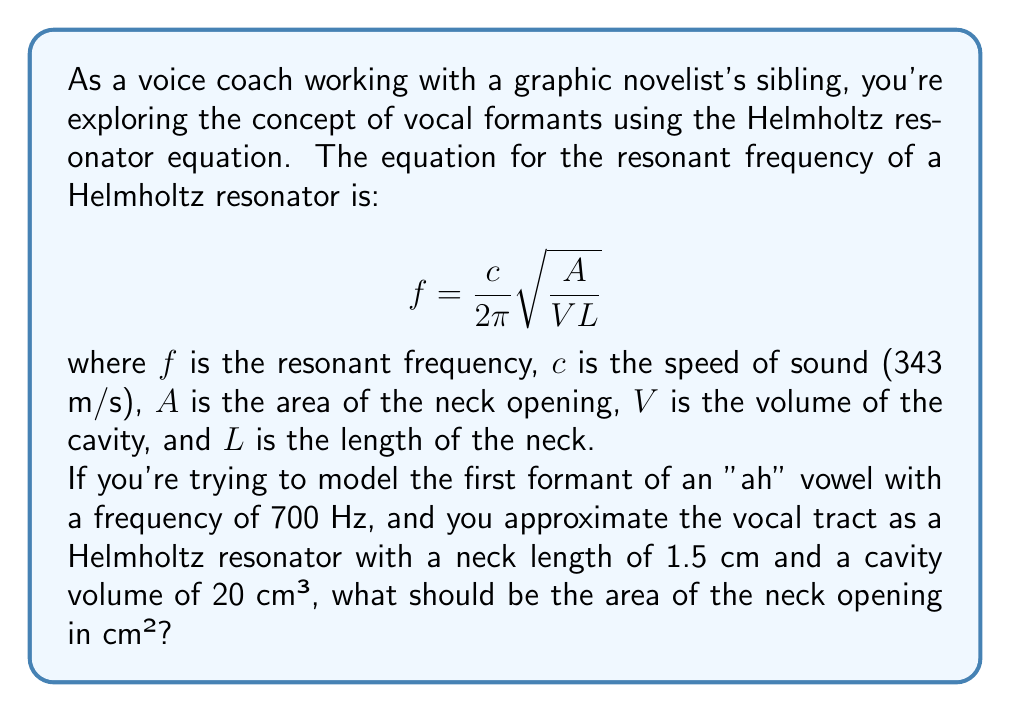Teach me how to tackle this problem. To solve this problem, we'll use the Helmholtz resonator equation and work backwards to find the area of the neck opening. Let's break it down step by step:

1) We're given:
   $f = 700$ Hz
   $c = 343$ m/s
   $L = 1.5$ cm $= 0.015$ m
   $V = 20$ cm³ $= 2 \times 10^{-5}$ m³

2) We need to solve for $A$. Let's rearrange the equation:

   $$f = \frac{c}{2\pi} \sqrt{\frac{A}{VL}}$$
   
   $$\frac{2\pi f}{c} = \sqrt{\frac{A}{VL}}$$
   
   $$\left(\frac{2\pi f}{c}\right)^2 = \frac{A}{VL}$$
   
   $$A = VL\left(\frac{2\pi f}{c}\right)^2$$

3) Now, let's substitute our values:

   $$A = (2 \times 10^{-5})(0.015)\left(\frac{2\pi(700)}{343}\right)^2$$

4) Let's calculate step by step:
   
   $$A = (3 \times 10^{-7})\left(\frac{4400\pi}{343}\right)^2$$
   
   $$A = (3 \times 10^{-7})(164.42)^2$$
   
   $$A = (3 \times 10^{-7})(27033.94)$$
   
   $$A = 8.11 \times 10^{-3} \text{ m}^2$$

5) Convert to cm²:
   
   $$A = 8.11 \times 10^{-3} \times 10000 = 81.1 \text{ cm}^2$$

Therefore, the area of the neck opening should be approximately 81.1 cm².
Answer: 81.1 cm² 